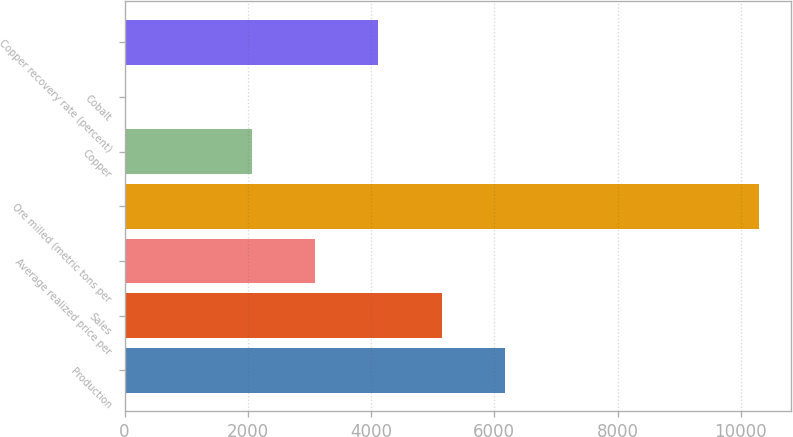<chart> <loc_0><loc_0><loc_500><loc_500><bar_chart><fcel>Production<fcel>Sales<fcel>Average realized price per<fcel>Ore milled (metric tons per<fcel>Copper<fcel>Cobalt<fcel>Copper recovery rate (percent)<nl><fcel>6180.16<fcel>5150.2<fcel>3090.28<fcel>10300<fcel>2060.32<fcel>0.4<fcel>4120.24<nl></chart> 